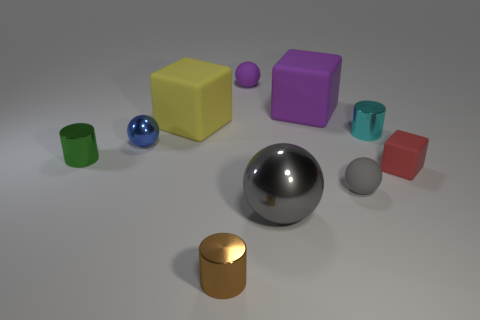Subtract all blocks. How many objects are left? 7 Subtract 0 gray cubes. How many objects are left? 10 Subtract all brown metal balls. Subtract all small gray objects. How many objects are left? 9 Add 8 purple things. How many purple things are left? 10 Add 5 tiny red matte cylinders. How many tiny red matte cylinders exist? 5 